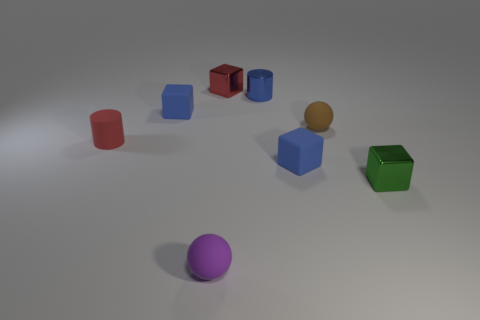How many objects are either small brown spheres or matte objects in front of the small green block?
Keep it short and to the point. 2. Is the number of things that are behind the brown matte sphere greater than the number of red rubber cylinders left of the red matte cylinder?
Your answer should be very brief. Yes. What is the cube that is to the right of the blue rubber cube to the right of the sphere that is in front of the tiny red matte cylinder made of?
Offer a terse response. Metal. What shape is the small red object that is made of the same material as the blue cylinder?
Your answer should be compact. Cube. There is a small blue thing that is in front of the small rubber cylinder; are there any blue objects left of it?
Your answer should be very brief. Yes. What number of things are either matte blocks or blue metal things?
Ensure brevity in your answer.  3. Is the tiny green thing that is to the right of the brown rubber object made of the same material as the thing that is in front of the green object?
Your answer should be compact. No. What is the color of the other small block that is the same material as the small green block?
Offer a terse response. Red. How many other brown matte things have the same size as the brown object?
Offer a very short reply. 0. How many other objects are there of the same color as the tiny shiny cylinder?
Your answer should be very brief. 2. 